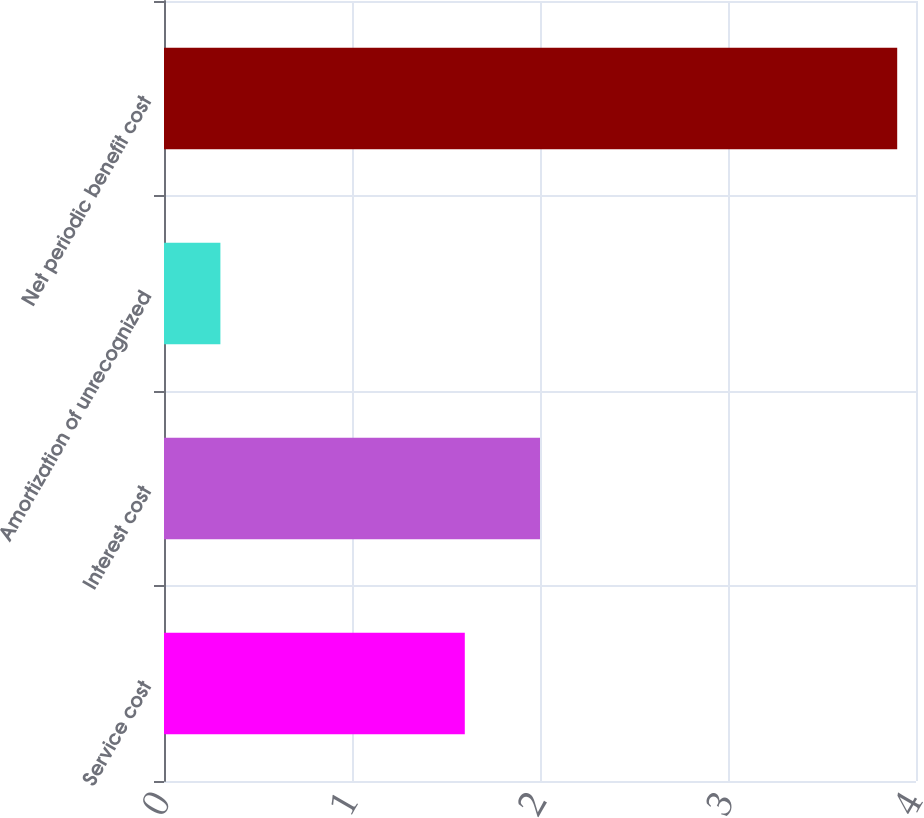Convert chart to OTSL. <chart><loc_0><loc_0><loc_500><loc_500><bar_chart><fcel>Service cost<fcel>Interest cost<fcel>Amortization of unrecognized<fcel>Net periodic benefit cost<nl><fcel>1.6<fcel>2<fcel>0.3<fcel>3.9<nl></chart> 